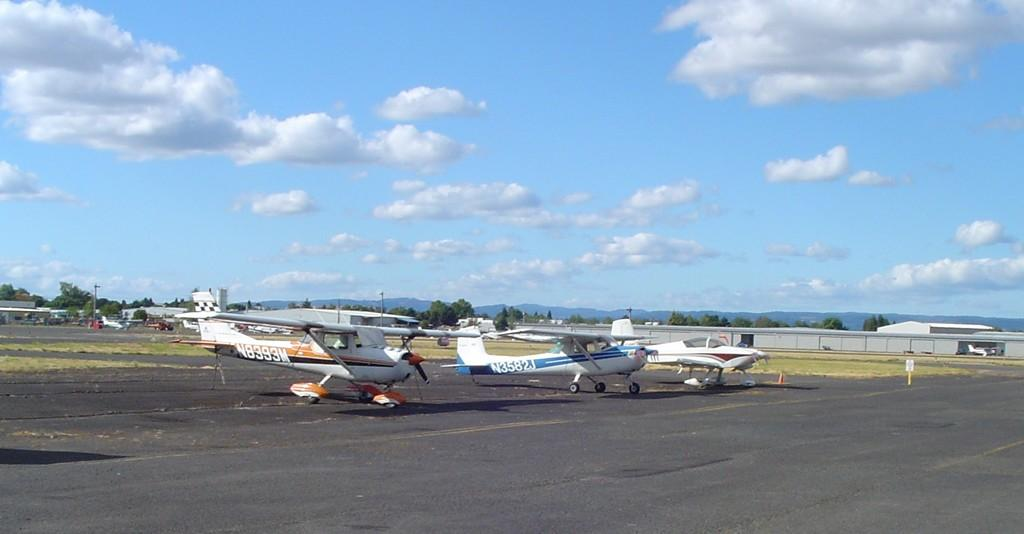<image>
Describe the image concisely. Plane N8393M sits next to two other small planes. 